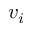Convert formula to latex. <formula><loc_0><loc_0><loc_500><loc_500>v _ { i }</formula> 